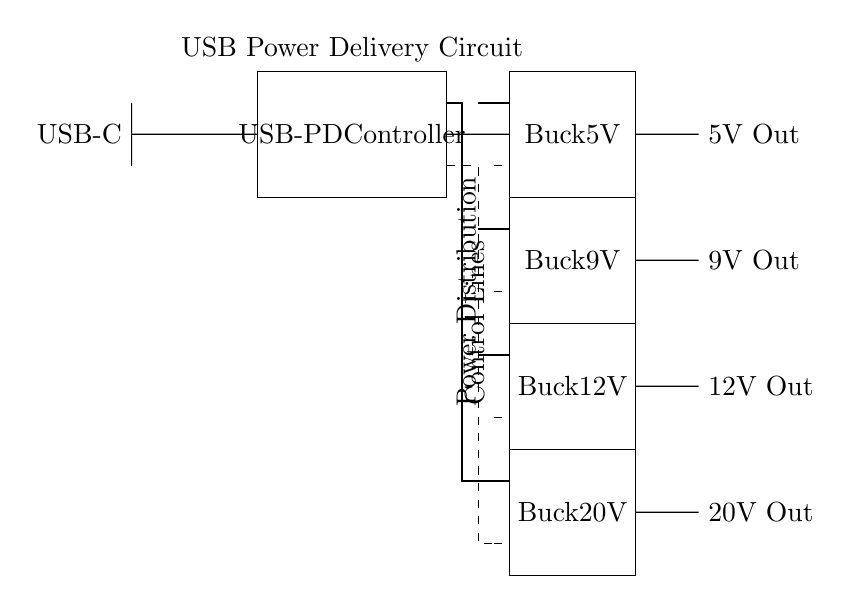What is the main component of this circuit? The main component is the USB-PD Controller, which is responsible for managing power delivery within the circuit.
Answer: USB-PD Controller How many voltage outputs are available in this circuit? The circuit provides four different voltage outputs: 5V, 9V, 12V, and 20V.
Answer: Four What is the purpose of the buck converters in this circuit? The buck converters convert a higher input voltage down to lower output voltages required by devices, ensuring compatibility with various power requirements.
Answer: Voltage conversion What are the output voltages of this circuit? The outputs of the circuit are: 5V Out, 9V Out, 12V Out, and 20V Out, as marked in the diagram.
Answer: 5V, 9V, 12V, 20V What indicates the control lines in the circuit? The control lines are represented by dashed lines which connect the USB-PD Controller to each buck converter for communication and management purposes.
Answer: Dashed lines How does the power distribution system function in this circuit? The power distribution system is managed through the thick power lines that connect the USB-PD Controller to each buck converter, directing power to the appropriate output voltage.
Answer: Power lines What role does the USB-C connector play in this circuit? The USB-C connector serves as the input interface, allowing power to flow from an external source into the USB-PD Controller for further distribution.
Answer: Input interface 